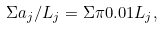Convert formula to latex. <formula><loc_0><loc_0><loc_500><loc_500>\Sigma a _ { j } / L _ { j } = \Sigma \pi 0 . 0 1 L _ { j } ,</formula> 